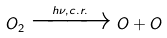Convert formula to latex. <formula><loc_0><loc_0><loc_500><loc_500>O _ { 2 } \xrightarrow { h \nu , c . r . } O + O</formula> 